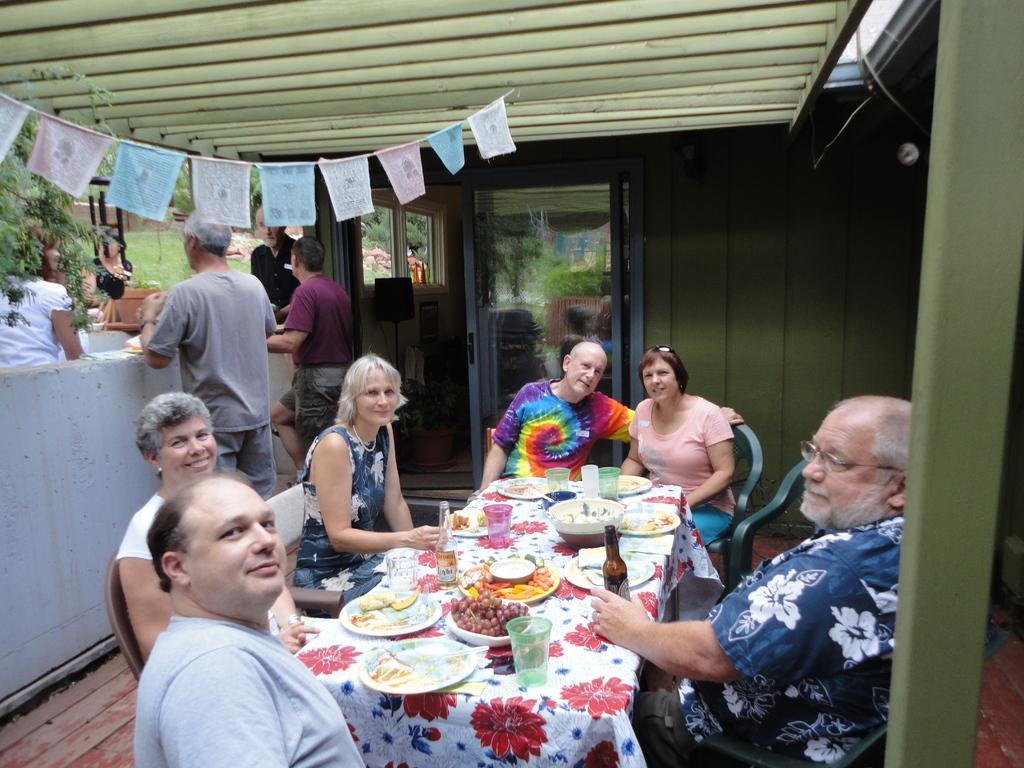Can you describe this image briefly? In this picture we can see a group of people sitting at the table, the table has a wine bottle, fruits and food. There is a door in the backdrop. 